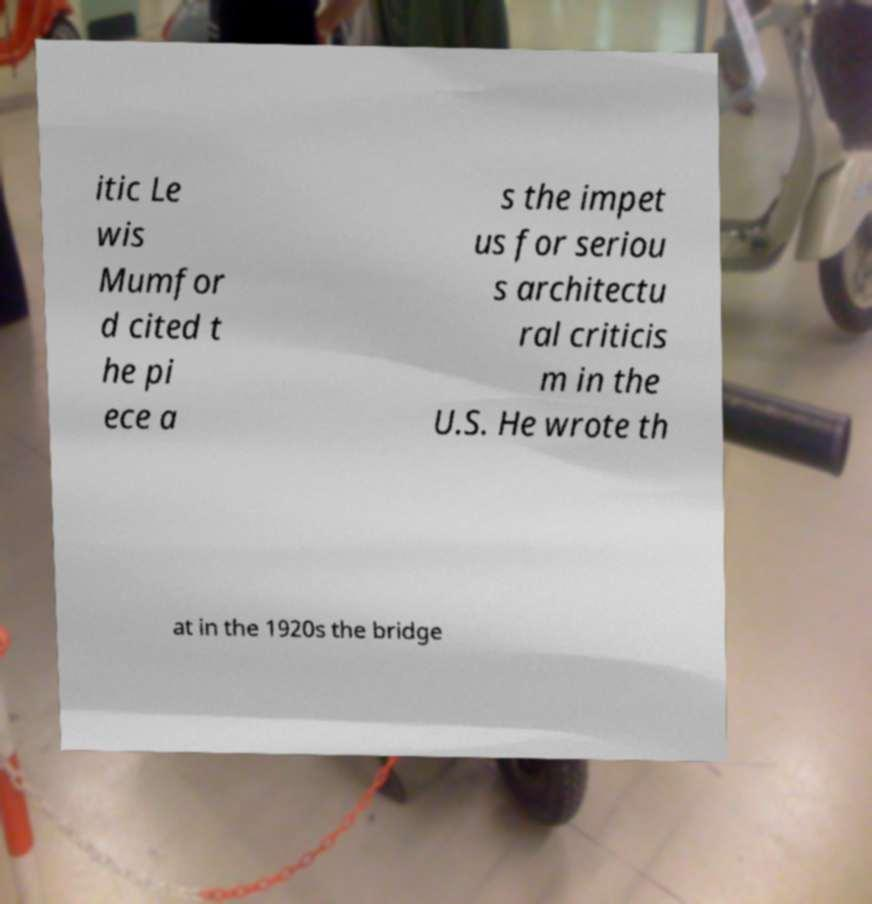What messages or text are displayed in this image? I need them in a readable, typed format. itic Le wis Mumfor d cited t he pi ece a s the impet us for seriou s architectu ral criticis m in the U.S. He wrote th at in the 1920s the bridge 